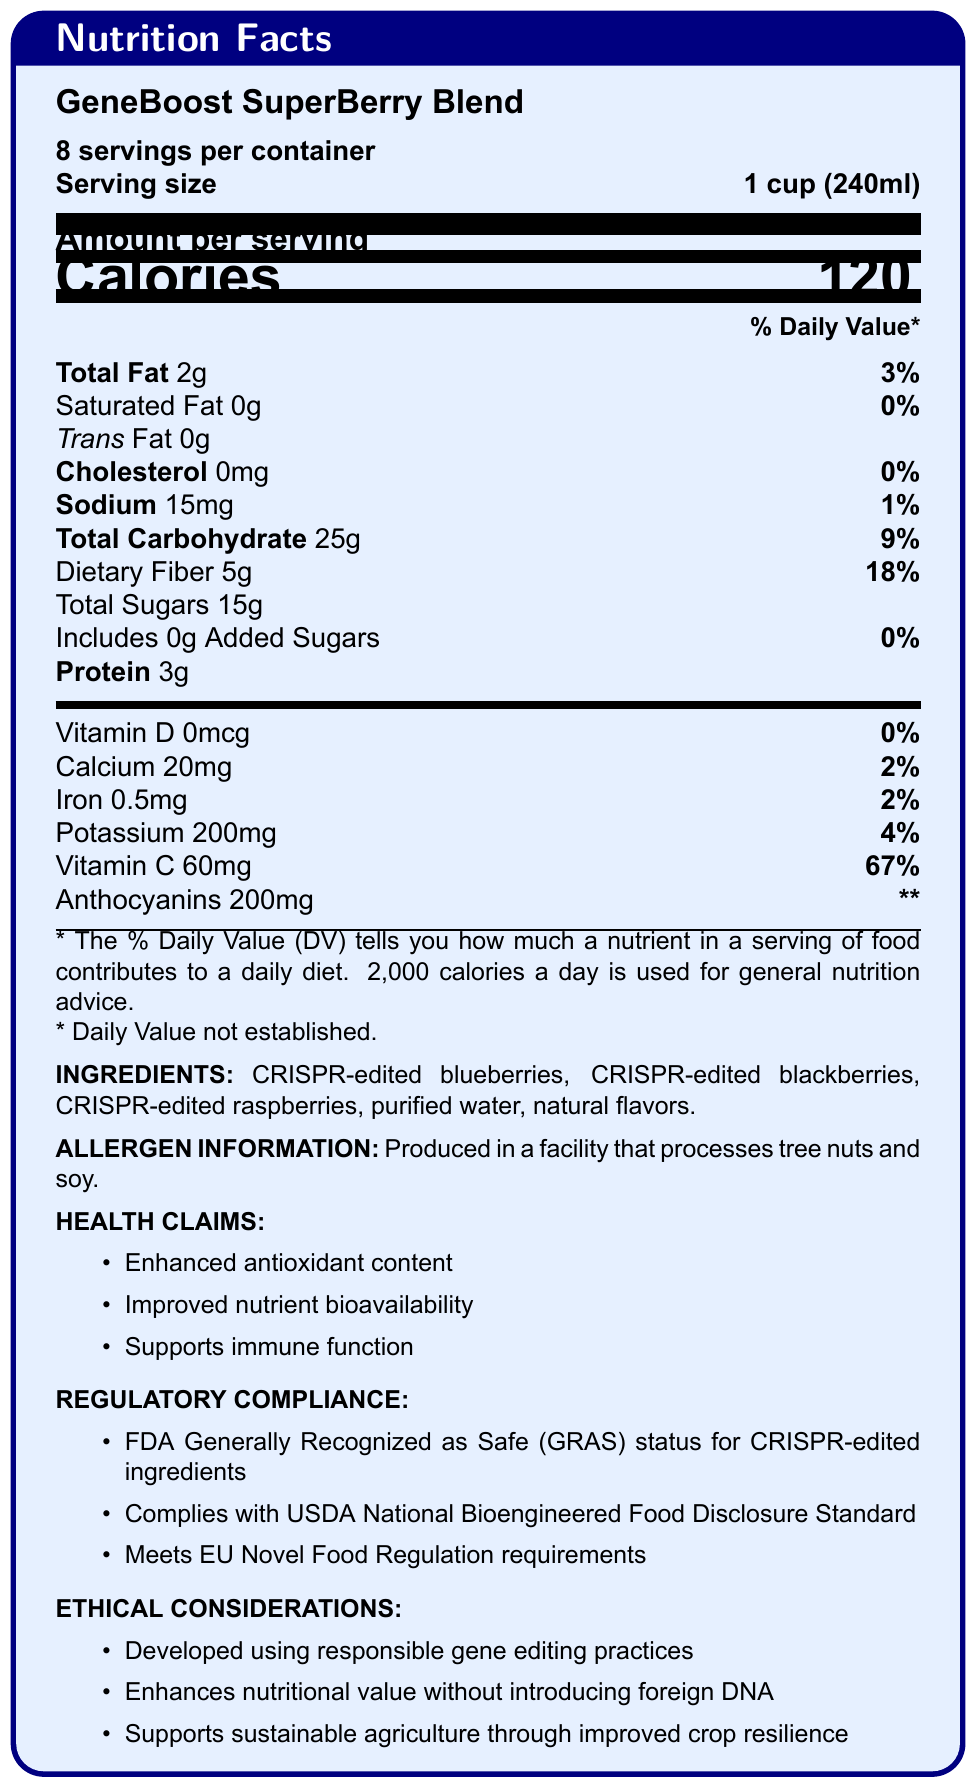What is the serving size of GeneBoost SuperBerry Blend? The serving size is indicated near the top of the document, immediately following "Serving size."
Answer: 1 cup (240ml) How many calories are there per serving? The amount of calories per serving is listed as "Calories 120" under the "Amount per serving" section.
Answer: 120 What percentage of the daily value of dietary fiber does one serving provide? The daily value percentage for dietary fiber is shown in the document as "Dietary Fiber 5g 18%".
Answer: 18% Which ingredient in GeneBoost SuperBerry Blend is not CRISPR-edited? The list of ingredients includes CRISPR-edited blueberries, blackberries, raspberries, purified water, and natural flavors. Among them, purified water is not CRISPR-edited.
Answer: Purified water What is the total amount of sugars per serving? Under "Total Sugars," it is indicated as "Total Sugars 15g."
Answer: 15g What regulatory compliance standards does GeneBoost SuperBerry Blend meet? A. FDA GRAS B. USDA National Bioengineered Food Disclosure Standard C. EU Novel Food Regulation D. All of the above The document lists three compliance standards that the product meets: FDA GRAS, USDA National Bioengineered Food Disclosure Standard, and EU Novel Food Regulation requirements.
Answer: D. All of the above Which of the following vitamins has the highest daily value percentage per serving in the product? I. Vitamin D II. Calcium III. Iron IV. Vitamin C The daily value percentages for vitamins are listed as: Vitamin D (0%), Calcium (2%), Iron (2%), and Vitamin C (67%). Vitamin C has the highest daily value percentage.
Answer: IV. Vitamin C Does GeneBoost SuperBerry Blend contain any added sugars? The document states "Includes 0g Added Sugars" under the total sugars section.
Answer: No Summarize the main attributes of GeneBoost SuperBerry Blend. The document highlights the main features, ingredients, health claims, regulatory compliance, and ethical considerations of the product while detailing its nutritional content.
Answer: GeneBoost SuperBerry Blend is a functional food product with CRISPR-edited ingredients such as blueberries, blackberries, and raspberries. It provides enhanced antioxidant content, improved nutrient bioavailability, and supports immune function. It meets various regulatory compliances and is developed using responsible gene editing practices. Nutritional facts show it is low in fat, contains dietary fiber and natural sugars, and provides a significant amount of Vitamin C. What is the facility allergen information for this product? This information is located towards the bottom of the document under "ALLERGEN INFORMATION."
Answer: Produced in a facility that processes tree nuts and soy. How much protein is there per serving? The document lists the protein amount as "Protein 3g."
Answer: 3g Does the product's use of CRISPR technology include the introduction of foreign DNA? Under "ETHICAL CONSIDERATIONS," it states that the product "enhances nutritional value without introducing foreign DNA."
Answer: No What are anthocyanins, and why are they significant? The document lists the amount of anthocyanins but does not provide specific information about what they are or why they are significant.
Answer: Cannot be determined What is the sodium content per serving? The sodium content per serving is listed as "Sodium 15mg 1%."
Answer: 15mg What health claims are made about GeneBoost SuperBerry Blend? These health claims are explicitly listed under "HEALTH CLAIMS."
Answer: Enhanced antioxidant content, improved nutrient bioavailability, supports immune function Is GeneBoost SuperBerry Blend compliant with the USDA National Bioengineered Food Disclosure Standard? Compliance with the USDA National Bioengineered Food Disclosure Standard is listed under "REGULATORY COMPLIANCE."
Answer: Yes What ethical considerations are associated with this product? These ethical considerations are clearly listed under "ETHICAL CONSIDERATIONS."
Answer: Developed using responsible gene editing practices, enhances nutritional value without introducing foreign DNA, supports sustainable agriculture through improved crop resilience What is the percent daily value of potassium provided by one serving? The daily value percentage for potassium is listed as "Potassium 200mg 4%."
Answer: 4% In what kind of facility is GeneBoost SuperBerry Blend produced? This information is located in the "ALLERGEN INFORMATION" section.
Answer: Produced in a facility that processes tree nuts and soy. What is the percent daily value of iron provided by one serving? The iron content is shown as "Iron 0.5mg 2%."
Answer: 2% Does the product contain any trans fat? The document states, "Trans Fat 0g."
Answer: No 